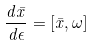<formula> <loc_0><loc_0><loc_500><loc_500>\frac { d \bar { x } } { d { \epsilon } } = \left [ \bar { x } , \omega \right ]</formula> 